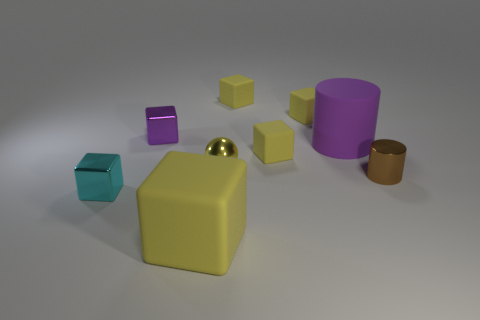Add 1 green spheres. How many objects exist? 10 Subtract all spheres. How many objects are left? 8 Subtract all metallic cubes. How many cubes are left? 4 Subtract all small objects. Subtract all small spheres. How many objects are left? 1 Add 1 large blocks. How many large blocks are left? 2 Add 4 balls. How many balls exist? 5 Subtract all purple cylinders. How many cylinders are left? 1 Subtract 0 green cubes. How many objects are left? 9 Subtract 3 blocks. How many blocks are left? 3 Subtract all green blocks. Subtract all gray balls. How many blocks are left? 6 